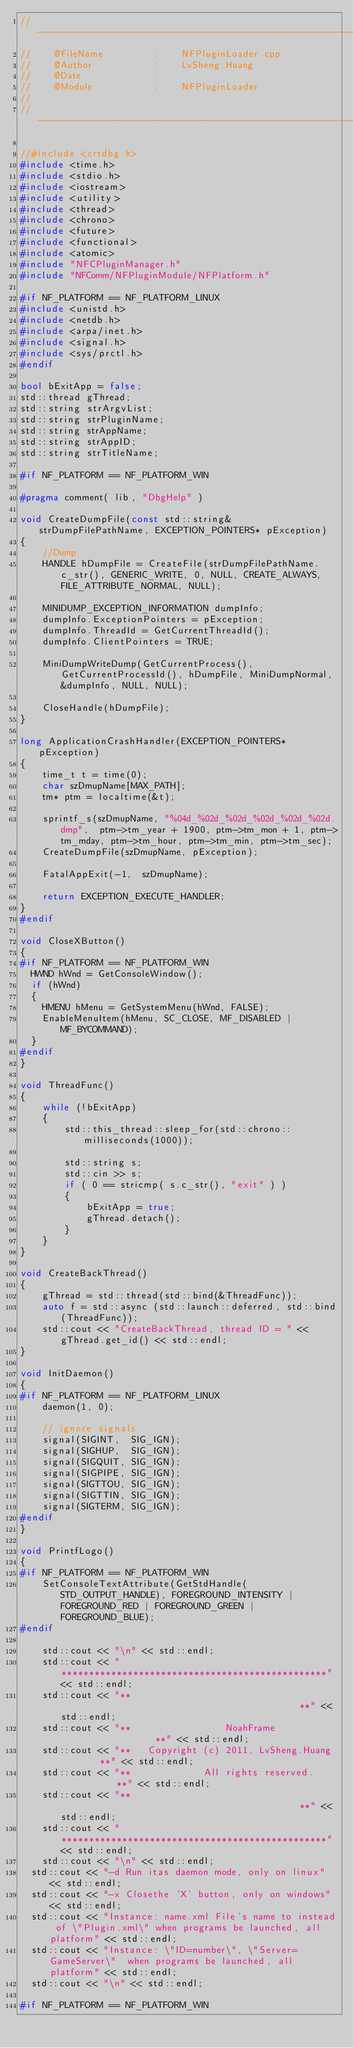Convert code to text. <code><loc_0><loc_0><loc_500><loc_500><_C++_>// -------------------------------------------------------------------------
//    @FileName         :    NFPluginLoader.cpp
//    @Author           :    LvSheng.Huang
//    @Date             :
//    @Module           :    NFPluginLoader
//
// -------------------------------------------------------------------------

//#include <crtdbg.h>
#include <time.h>
#include <stdio.h>
#include <iostream>
#include <utility>
#include <thread>
#include <chrono>
#include <future>
#include <functional>
#include <atomic>
#include "NFCPluginManager.h"
#include "NFComm/NFPluginModule/NFPlatform.h"

#if NF_PLATFORM == NF_PLATFORM_LINUX
#include <unistd.h>
#include <netdb.h>
#include <arpa/inet.h>
#include <signal.h>
#include <sys/prctl.h>
#endif

bool bExitApp = false;
std::thread gThread;
std::string strArgvList;
std::string strPluginName;
std::string strAppName;
std::string strAppID;
std::string strTitleName;

#if NF_PLATFORM == NF_PLATFORM_WIN

#pragma comment( lib, "DbgHelp" )

void CreateDumpFile(const std::string& strDumpFilePathName, EXCEPTION_POINTERS* pException)
{
    //Dump
    HANDLE hDumpFile = CreateFile(strDumpFilePathName.c_str(), GENERIC_WRITE, 0, NULL, CREATE_ALWAYS, FILE_ATTRIBUTE_NORMAL, NULL);

    MINIDUMP_EXCEPTION_INFORMATION dumpInfo;
    dumpInfo.ExceptionPointers = pException;
    dumpInfo.ThreadId = GetCurrentThreadId();
    dumpInfo.ClientPointers = TRUE;

    MiniDumpWriteDump(GetCurrentProcess(), GetCurrentProcessId(), hDumpFile, MiniDumpNormal, &dumpInfo, NULL, NULL);

    CloseHandle(hDumpFile);
}

long ApplicationCrashHandler(EXCEPTION_POINTERS* pException)
{
    time_t t = time(0);
    char szDmupName[MAX_PATH];
    tm* ptm = localtime(&t);

    sprintf_s(szDmupName, "%04d_%02d_%02d_%02d_%02d_%02d.dmp",  ptm->tm_year + 1900, ptm->tm_mon + 1, ptm->tm_mday, ptm->tm_hour, ptm->tm_min, ptm->tm_sec);
    CreateDumpFile(szDmupName, pException);

    FatalAppExit(-1,  szDmupName);

    return EXCEPTION_EXECUTE_HANDLER;
}
#endif

void CloseXButton()
{
#if NF_PLATFORM == NF_PLATFORM_WIN
	HWND hWnd = GetConsoleWindow();
	if (hWnd)
	{
		HMENU hMenu = GetSystemMenu(hWnd, FALSE);
		EnableMenuItem(hMenu, SC_CLOSE, MF_DISABLED | MF_BYCOMMAND);
	}
#endif
}

void ThreadFunc()
{
    while (!bExitApp)
    {
        std::this_thread::sleep_for(std::chrono::milliseconds(1000));

        std::string s;
        std::cin >> s;
        if ( 0 == stricmp( s.c_str(), "exit" ) )
        {
            bExitApp = true;
            gThread.detach();
        }
    }
}

void CreateBackThread()
{
    gThread = std::thread(std::bind(&ThreadFunc));
    auto f = std::async (std::launch::deferred, std::bind(ThreadFunc));
    std::cout << "CreateBackThread, thread ID = " << gThread.get_id() << std::endl;
}

void InitDaemon()
{
#if NF_PLATFORM == NF_PLATFORM_LINUX
    daemon(1, 0);

    // ignore signals
    signal(SIGINT,  SIG_IGN);
    signal(SIGHUP,  SIG_IGN);
    signal(SIGQUIT, SIG_IGN);
    signal(SIGPIPE, SIG_IGN);
    signal(SIGTTOU, SIG_IGN);
    signal(SIGTTIN, SIG_IGN);
    signal(SIGTERM, SIG_IGN);
#endif
}

void PrintfLogo()
{
#if NF_PLATFORM == NF_PLATFORM_WIN
    SetConsoleTextAttribute(GetStdHandle(STD_OUTPUT_HANDLE), FOREGROUND_INTENSITY | FOREGROUND_RED | FOREGROUND_GREEN | FOREGROUND_BLUE);
#endif

    std::cout << "\n" << std::endl;
    std::cout << "************************************************" << std::endl;
    std::cout << "**                                            **" << std::endl;
    std::cout << "**                 NoahFrame                  **" << std::endl;
    std::cout << "**   Copyright (c) 2011, LvSheng.Huang        **" << std::endl;
    std::cout << "**             All rights reserved.           **" << std::endl;
    std::cout << "**                                            **" << std::endl;
    std::cout << "************************************************" << std::endl;
    std::cout << "\n" << std::endl;
	std::cout << "-d Run itas daemon mode, only on linux" << std::endl;
	std::cout << "-x Closethe 'X' button, only on windows" << std::endl;
	std::cout << "Instance: name.xml File's name to instead of \"Plugin.xml\" when programs be launched, all platform" << std::endl;
	std::cout << "Instance: \"ID=number\", \"Server=GameServer\"  when programs be launched, all platform" << std::endl;
	std::cout << "\n" << std::endl;

#if NF_PLATFORM == NF_PLATFORM_WIN</code> 